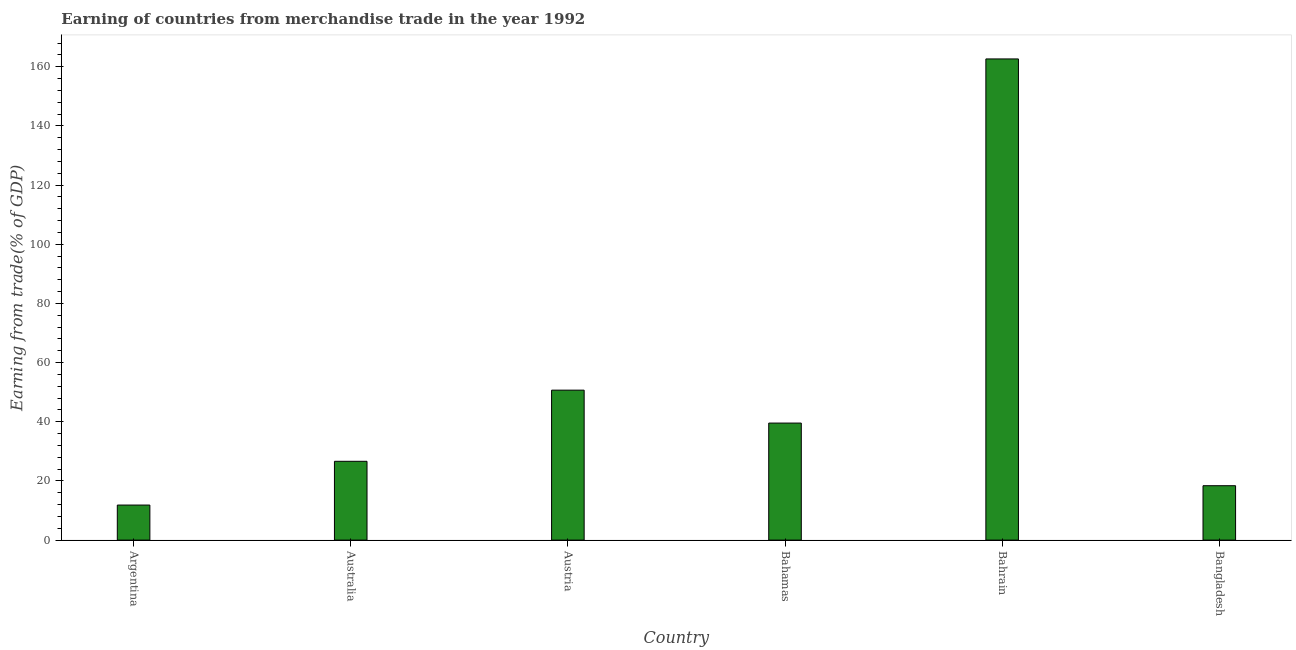What is the title of the graph?
Give a very brief answer. Earning of countries from merchandise trade in the year 1992. What is the label or title of the Y-axis?
Provide a succinct answer. Earning from trade(% of GDP). What is the earning from merchandise trade in Australia?
Give a very brief answer. 26.63. Across all countries, what is the maximum earning from merchandise trade?
Keep it short and to the point. 162.66. Across all countries, what is the minimum earning from merchandise trade?
Provide a short and direct response. 11.85. In which country was the earning from merchandise trade maximum?
Offer a very short reply. Bahrain. In which country was the earning from merchandise trade minimum?
Offer a very short reply. Argentina. What is the sum of the earning from merchandise trade?
Your answer should be compact. 309.78. What is the difference between the earning from merchandise trade in Australia and Bangladesh?
Make the answer very short. 8.25. What is the average earning from merchandise trade per country?
Give a very brief answer. 51.63. What is the median earning from merchandise trade?
Give a very brief answer. 33.1. What is the ratio of the earning from merchandise trade in Argentina to that in Australia?
Give a very brief answer. 0.45. Is the earning from merchandise trade in Argentina less than that in Australia?
Ensure brevity in your answer.  Yes. Is the difference between the earning from merchandise trade in Argentina and Australia greater than the difference between any two countries?
Offer a terse response. No. What is the difference between the highest and the second highest earning from merchandise trade?
Offer a very short reply. 111.97. What is the difference between the highest and the lowest earning from merchandise trade?
Offer a very short reply. 150.81. Are the values on the major ticks of Y-axis written in scientific E-notation?
Keep it short and to the point. No. What is the Earning from trade(% of GDP) in Argentina?
Provide a short and direct response. 11.85. What is the Earning from trade(% of GDP) in Australia?
Your response must be concise. 26.63. What is the Earning from trade(% of GDP) in Austria?
Your answer should be compact. 50.69. What is the Earning from trade(% of GDP) in Bahamas?
Your answer should be very brief. 39.56. What is the Earning from trade(% of GDP) in Bahrain?
Make the answer very short. 162.66. What is the Earning from trade(% of GDP) in Bangladesh?
Ensure brevity in your answer.  18.39. What is the difference between the Earning from trade(% of GDP) in Argentina and Australia?
Ensure brevity in your answer.  -14.79. What is the difference between the Earning from trade(% of GDP) in Argentina and Austria?
Offer a very short reply. -38.84. What is the difference between the Earning from trade(% of GDP) in Argentina and Bahamas?
Ensure brevity in your answer.  -27.71. What is the difference between the Earning from trade(% of GDP) in Argentina and Bahrain?
Give a very brief answer. -150.81. What is the difference between the Earning from trade(% of GDP) in Argentina and Bangladesh?
Provide a short and direct response. -6.54. What is the difference between the Earning from trade(% of GDP) in Australia and Austria?
Give a very brief answer. -24.06. What is the difference between the Earning from trade(% of GDP) in Australia and Bahamas?
Your answer should be compact. -12.93. What is the difference between the Earning from trade(% of GDP) in Australia and Bahrain?
Make the answer very short. -136.02. What is the difference between the Earning from trade(% of GDP) in Australia and Bangladesh?
Provide a succinct answer. 8.25. What is the difference between the Earning from trade(% of GDP) in Austria and Bahamas?
Offer a terse response. 11.13. What is the difference between the Earning from trade(% of GDP) in Austria and Bahrain?
Your answer should be very brief. -111.97. What is the difference between the Earning from trade(% of GDP) in Austria and Bangladesh?
Your answer should be very brief. 32.31. What is the difference between the Earning from trade(% of GDP) in Bahamas and Bahrain?
Your response must be concise. -123.1. What is the difference between the Earning from trade(% of GDP) in Bahamas and Bangladesh?
Give a very brief answer. 21.18. What is the difference between the Earning from trade(% of GDP) in Bahrain and Bangladesh?
Ensure brevity in your answer.  144.27. What is the ratio of the Earning from trade(% of GDP) in Argentina to that in Australia?
Keep it short and to the point. 0.45. What is the ratio of the Earning from trade(% of GDP) in Argentina to that in Austria?
Your answer should be very brief. 0.23. What is the ratio of the Earning from trade(% of GDP) in Argentina to that in Bahamas?
Your answer should be compact. 0.3. What is the ratio of the Earning from trade(% of GDP) in Argentina to that in Bahrain?
Keep it short and to the point. 0.07. What is the ratio of the Earning from trade(% of GDP) in Argentina to that in Bangladesh?
Your answer should be very brief. 0.64. What is the ratio of the Earning from trade(% of GDP) in Australia to that in Austria?
Give a very brief answer. 0.53. What is the ratio of the Earning from trade(% of GDP) in Australia to that in Bahamas?
Provide a succinct answer. 0.67. What is the ratio of the Earning from trade(% of GDP) in Australia to that in Bahrain?
Your answer should be compact. 0.16. What is the ratio of the Earning from trade(% of GDP) in Australia to that in Bangladesh?
Ensure brevity in your answer.  1.45. What is the ratio of the Earning from trade(% of GDP) in Austria to that in Bahamas?
Give a very brief answer. 1.28. What is the ratio of the Earning from trade(% of GDP) in Austria to that in Bahrain?
Offer a very short reply. 0.31. What is the ratio of the Earning from trade(% of GDP) in Austria to that in Bangladesh?
Provide a short and direct response. 2.76. What is the ratio of the Earning from trade(% of GDP) in Bahamas to that in Bahrain?
Offer a very short reply. 0.24. What is the ratio of the Earning from trade(% of GDP) in Bahamas to that in Bangladesh?
Make the answer very short. 2.15. What is the ratio of the Earning from trade(% of GDP) in Bahrain to that in Bangladesh?
Ensure brevity in your answer.  8.85. 